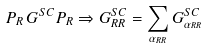<formula> <loc_0><loc_0><loc_500><loc_500>P _ { R } \, G ^ { S C } P _ { R } \Rightarrow G _ { R R } ^ { S C } = \sum _ { \alpha _ { R R } } G _ { \alpha _ { R R } } ^ { S C }</formula> 